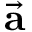<formula> <loc_0><loc_0><loc_500><loc_500>\vec { a }</formula> 